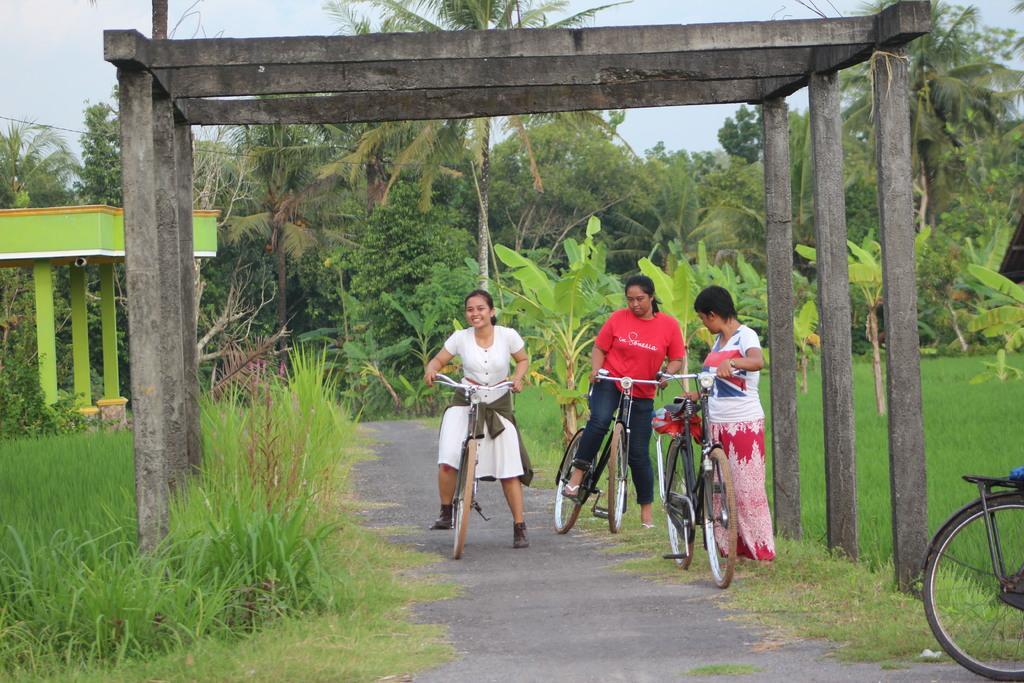Describe this image in one or two sentences. There are three girls holding bicycle in their hands. This girl is having a pretty smile on her face. This is a farm on the right side. In the background there are trees. 